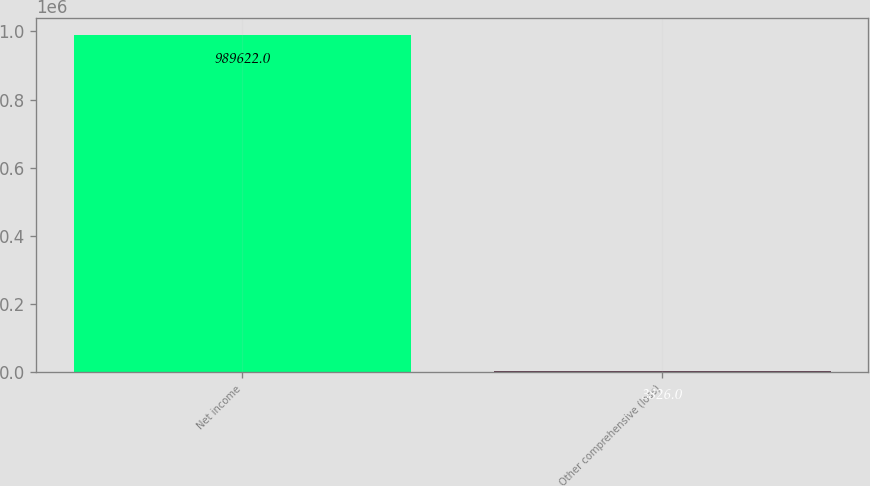<chart> <loc_0><loc_0><loc_500><loc_500><bar_chart><fcel>Net income<fcel>Other comprehensive (loss)<nl><fcel>989622<fcel>3826<nl></chart> 